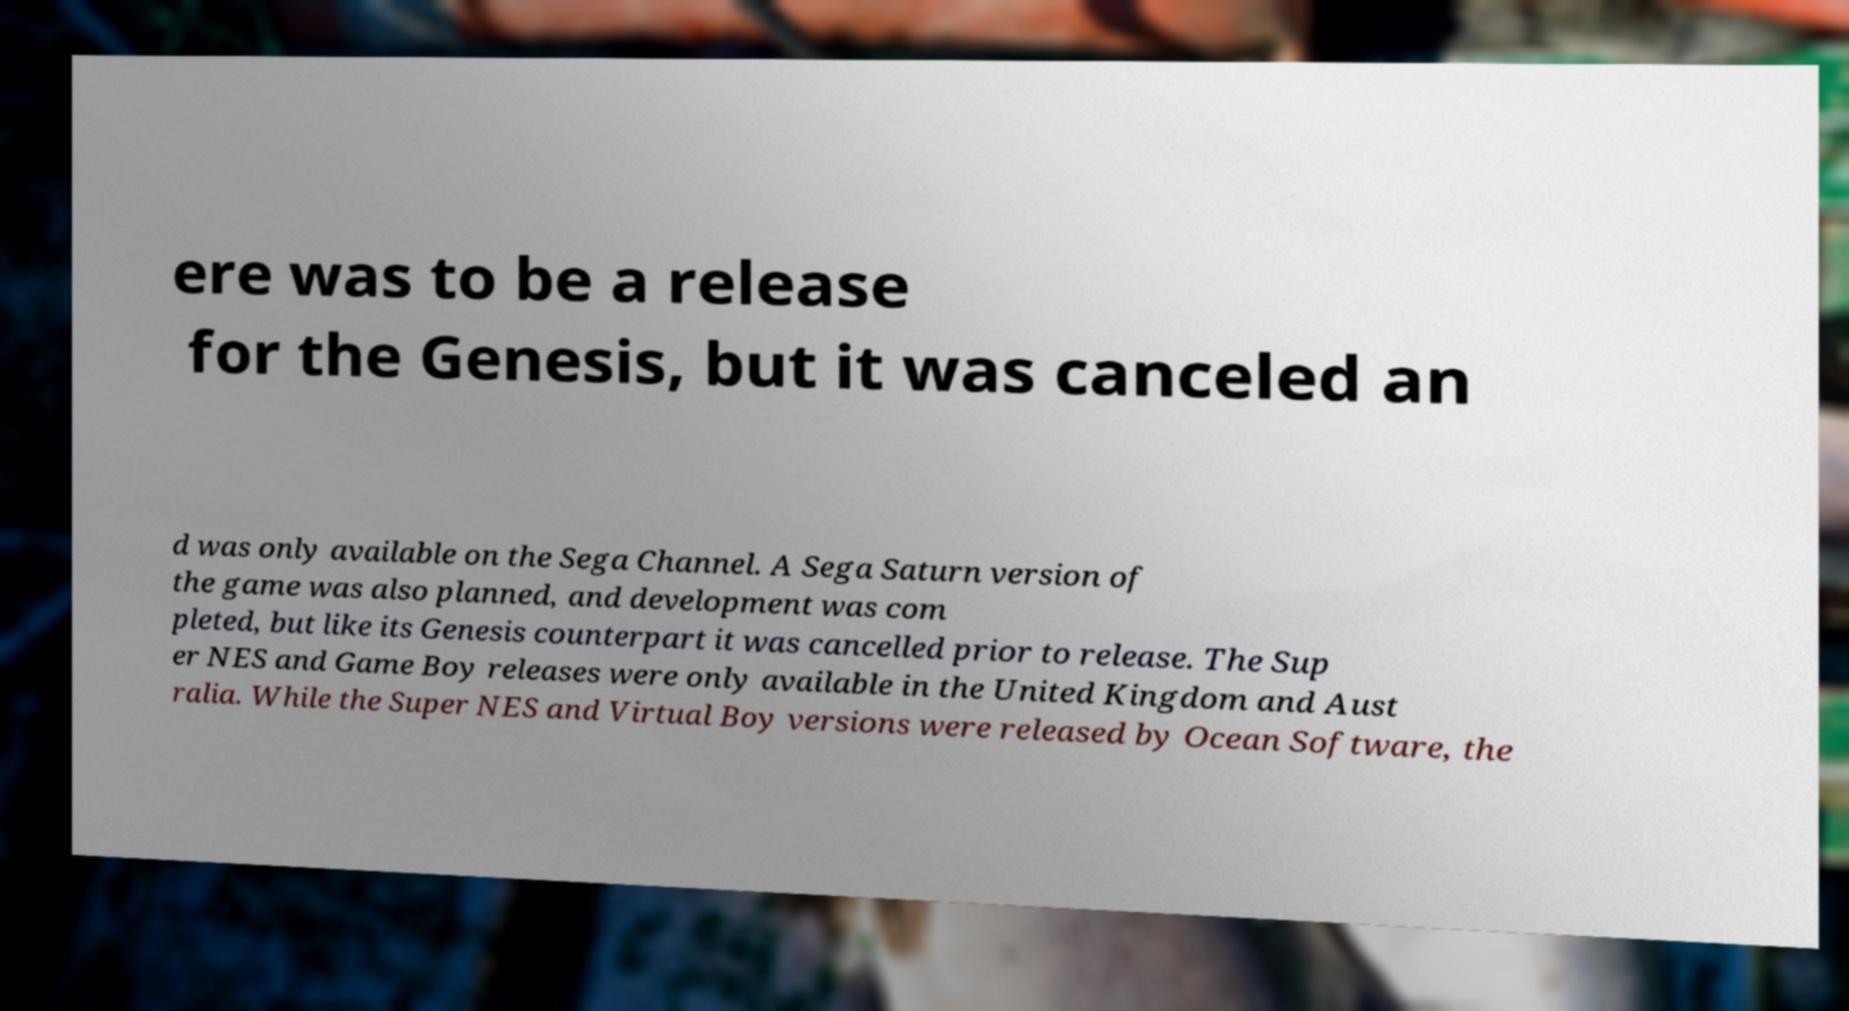Please identify and transcribe the text found in this image. ere was to be a release for the Genesis, but it was canceled an d was only available on the Sega Channel. A Sega Saturn version of the game was also planned, and development was com pleted, but like its Genesis counterpart it was cancelled prior to release. The Sup er NES and Game Boy releases were only available in the United Kingdom and Aust ralia. While the Super NES and Virtual Boy versions were released by Ocean Software, the 